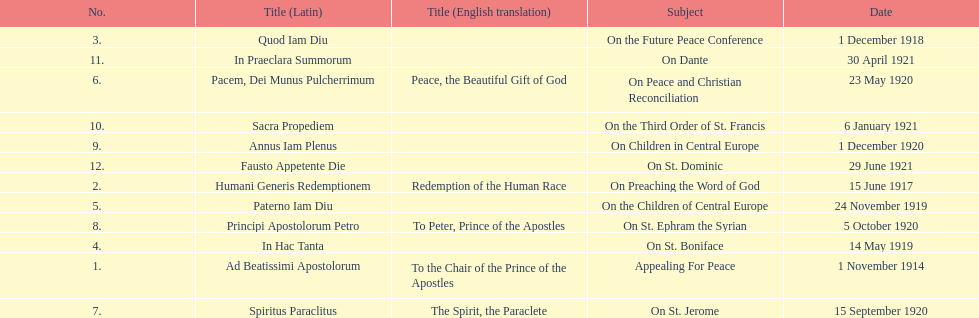Other than january how many encyclicals were in 1921? 2. 